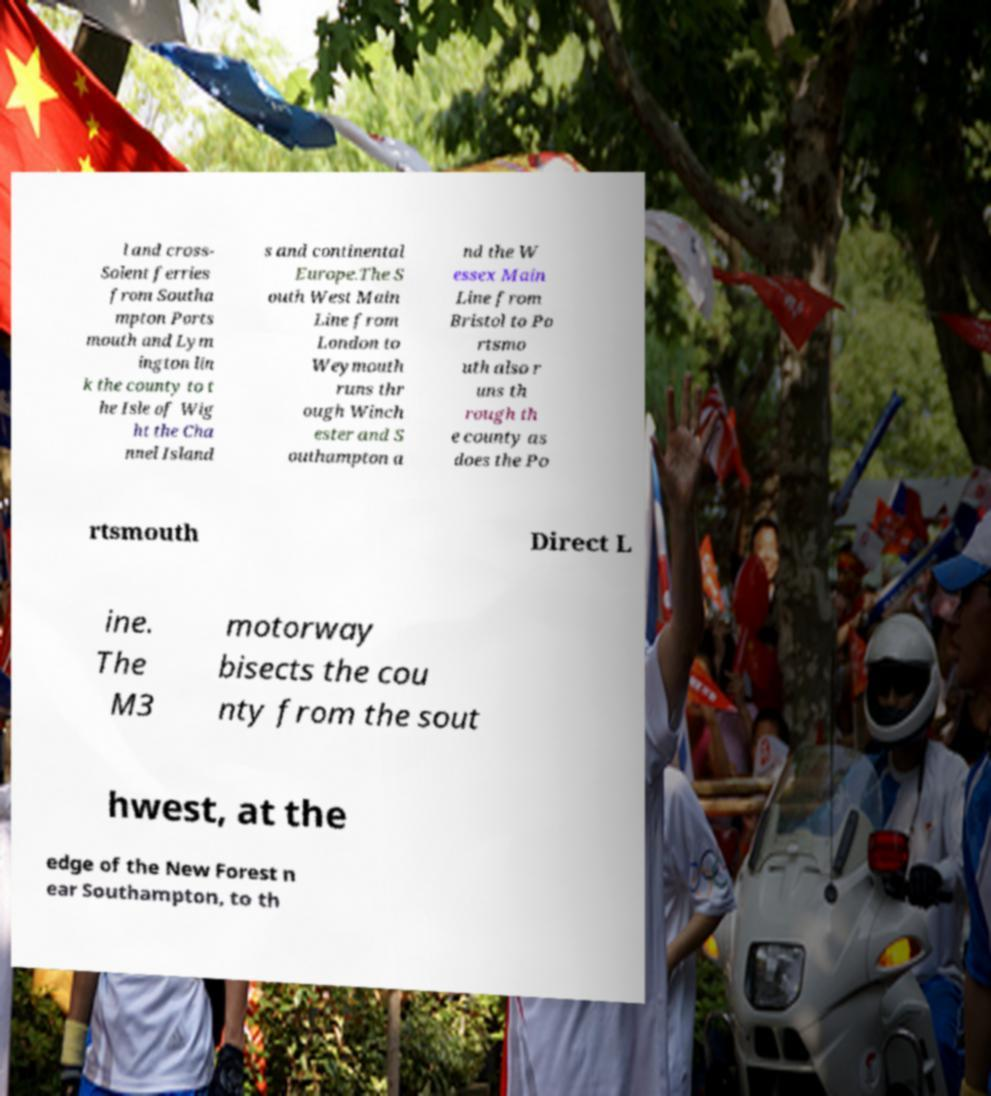There's text embedded in this image that I need extracted. Can you transcribe it verbatim? l and cross- Solent ferries from Southa mpton Ports mouth and Lym ington lin k the county to t he Isle of Wig ht the Cha nnel Island s and continental Europe.The S outh West Main Line from London to Weymouth runs thr ough Winch ester and S outhampton a nd the W essex Main Line from Bristol to Po rtsmo uth also r uns th rough th e county as does the Po rtsmouth Direct L ine. The M3 motorway bisects the cou nty from the sout hwest, at the edge of the New Forest n ear Southampton, to th 